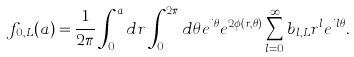Convert formula to latex. <formula><loc_0><loc_0><loc_500><loc_500>f _ { 0 , L } ( a ) = \frac { 1 } { 2 \pi } \int _ { 0 } ^ { a } d r \int _ { 0 } ^ { 2 \pi } d \theta e ^ { i \theta } e ^ { 2 \phi ( r , \theta ) } \sum _ { l = 0 } ^ { \infty } b _ { l , L } r ^ { l } e ^ { i l \theta } .</formula> 